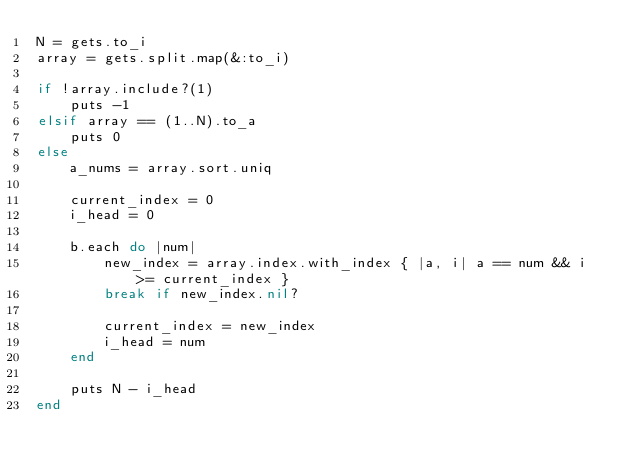<code> <loc_0><loc_0><loc_500><loc_500><_Ruby_>N = gets.to_i
array = gets.split.map(&:to_i)

if !array.include?(1)
    puts -1
elsif array == (1..N).to_a
    puts 0
else
    a_nums = array.sort.uniq
    
    current_index = 0
    i_head = 0
    
    b.each do |num|
        new_index = array.index.with_index { |a, i| a == num && i >= current_index }
        break if new_index.nil?
        
        current_index = new_index
        i_head = num
    end
    
    puts N - i_head
end</code> 